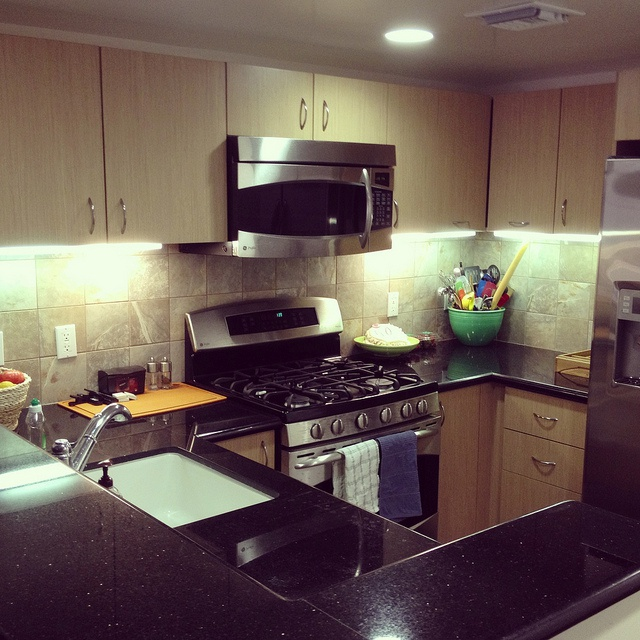Describe the objects in this image and their specific colors. I can see oven in brown, black, gray, and darkgray tones, microwave in brown, black, gray, and beige tones, refrigerator in brown, black, darkgray, and gray tones, sink in brown, beige, and black tones, and bowl in brown, green, black, and darkgreen tones in this image. 